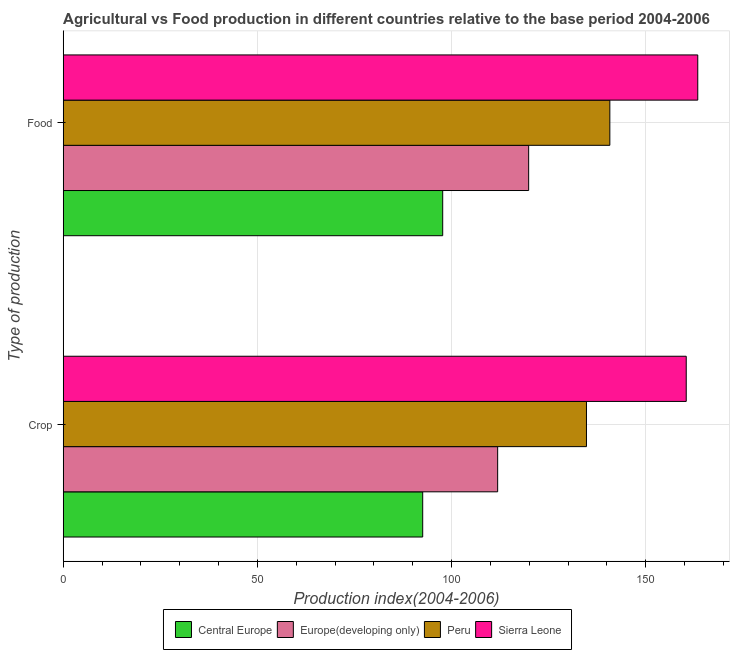How many different coloured bars are there?
Make the answer very short. 4. How many groups of bars are there?
Give a very brief answer. 2. Are the number of bars per tick equal to the number of legend labels?
Make the answer very short. Yes. Are the number of bars on each tick of the Y-axis equal?
Your response must be concise. Yes. How many bars are there on the 1st tick from the top?
Your answer should be compact. 4. How many bars are there on the 1st tick from the bottom?
Make the answer very short. 4. What is the label of the 2nd group of bars from the top?
Keep it short and to the point. Crop. What is the crop production index in Europe(developing only)?
Keep it short and to the point. 111.86. Across all countries, what is the maximum food production index?
Provide a succinct answer. 163.39. Across all countries, what is the minimum crop production index?
Give a very brief answer. 92.56. In which country was the food production index maximum?
Make the answer very short. Sierra Leone. In which country was the crop production index minimum?
Make the answer very short. Central Europe. What is the total food production index in the graph?
Your answer should be very brief. 521.7. What is the difference between the crop production index in Europe(developing only) and that in Central Europe?
Provide a short and direct response. 19.3. What is the difference between the food production index in Sierra Leone and the crop production index in Peru?
Ensure brevity in your answer.  28.66. What is the average food production index per country?
Offer a terse response. 130.42. What is the difference between the food production index and crop production index in Central Europe?
Offer a very short reply. 5.15. In how many countries, is the food production index greater than 130 ?
Give a very brief answer. 2. What is the ratio of the crop production index in Europe(developing only) to that in Sierra Leone?
Offer a terse response. 0.7. Is the food production index in Peru less than that in Europe(developing only)?
Your answer should be very brief. No. What does the 1st bar from the top in Food represents?
Your answer should be very brief. Sierra Leone. What does the 4th bar from the bottom in Crop represents?
Your response must be concise. Sierra Leone. Are the values on the major ticks of X-axis written in scientific E-notation?
Offer a very short reply. No. Does the graph contain any zero values?
Offer a very short reply. No. Does the graph contain grids?
Your response must be concise. Yes. What is the title of the graph?
Your answer should be compact. Agricultural vs Food production in different countries relative to the base period 2004-2006. Does "Timor-Leste" appear as one of the legend labels in the graph?
Give a very brief answer. No. What is the label or title of the X-axis?
Offer a very short reply. Production index(2004-2006). What is the label or title of the Y-axis?
Offer a terse response. Type of production. What is the Production index(2004-2006) of Central Europe in Crop?
Provide a short and direct response. 92.56. What is the Production index(2004-2006) of Europe(developing only) in Crop?
Offer a very short reply. 111.86. What is the Production index(2004-2006) in Peru in Crop?
Offer a very short reply. 134.73. What is the Production index(2004-2006) of Sierra Leone in Crop?
Your response must be concise. 160.42. What is the Production index(2004-2006) of Central Europe in Food?
Your answer should be very brief. 97.71. What is the Production index(2004-2006) of Europe(developing only) in Food?
Your answer should be compact. 119.84. What is the Production index(2004-2006) of Peru in Food?
Your answer should be very brief. 140.75. What is the Production index(2004-2006) of Sierra Leone in Food?
Your answer should be compact. 163.39. Across all Type of production, what is the maximum Production index(2004-2006) of Central Europe?
Offer a terse response. 97.71. Across all Type of production, what is the maximum Production index(2004-2006) in Europe(developing only)?
Make the answer very short. 119.84. Across all Type of production, what is the maximum Production index(2004-2006) in Peru?
Keep it short and to the point. 140.75. Across all Type of production, what is the maximum Production index(2004-2006) in Sierra Leone?
Make the answer very short. 163.39. Across all Type of production, what is the minimum Production index(2004-2006) in Central Europe?
Ensure brevity in your answer.  92.56. Across all Type of production, what is the minimum Production index(2004-2006) of Europe(developing only)?
Your answer should be very brief. 111.86. Across all Type of production, what is the minimum Production index(2004-2006) in Peru?
Provide a short and direct response. 134.73. Across all Type of production, what is the minimum Production index(2004-2006) of Sierra Leone?
Your response must be concise. 160.42. What is the total Production index(2004-2006) of Central Europe in the graph?
Your answer should be very brief. 190.27. What is the total Production index(2004-2006) in Europe(developing only) in the graph?
Give a very brief answer. 231.71. What is the total Production index(2004-2006) of Peru in the graph?
Keep it short and to the point. 275.48. What is the total Production index(2004-2006) of Sierra Leone in the graph?
Your response must be concise. 323.81. What is the difference between the Production index(2004-2006) of Central Europe in Crop and that in Food?
Ensure brevity in your answer.  -5.15. What is the difference between the Production index(2004-2006) in Europe(developing only) in Crop and that in Food?
Offer a terse response. -7.98. What is the difference between the Production index(2004-2006) of Peru in Crop and that in Food?
Provide a succinct answer. -6.02. What is the difference between the Production index(2004-2006) of Sierra Leone in Crop and that in Food?
Provide a short and direct response. -2.97. What is the difference between the Production index(2004-2006) in Central Europe in Crop and the Production index(2004-2006) in Europe(developing only) in Food?
Make the answer very short. -27.28. What is the difference between the Production index(2004-2006) of Central Europe in Crop and the Production index(2004-2006) of Peru in Food?
Offer a terse response. -48.19. What is the difference between the Production index(2004-2006) in Central Europe in Crop and the Production index(2004-2006) in Sierra Leone in Food?
Ensure brevity in your answer.  -70.83. What is the difference between the Production index(2004-2006) of Europe(developing only) in Crop and the Production index(2004-2006) of Peru in Food?
Make the answer very short. -28.89. What is the difference between the Production index(2004-2006) in Europe(developing only) in Crop and the Production index(2004-2006) in Sierra Leone in Food?
Make the answer very short. -51.53. What is the difference between the Production index(2004-2006) of Peru in Crop and the Production index(2004-2006) of Sierra Leone in Food?
Your answer should be compact. -28.66. What is the average Production index(2004-2006) of Central Europe per Type of production?
Ensure brevity in your answer.  95.14. What is the average Production index(2004-2006) of Europe(developing only) per Type of production?
Offer a terse response. 115.85. What is the average Production index(2004-2006) in Peru per Type of production?
Your answer should be compact. 137.74. What is the average Production index(2004-2006) of Sierra Leone per Type of production?
Ensure brevity in your answer.  161.91. What is the difference between the Production index(2004-2006) of Central Europe and Production index(2004-2006) of Europe(developing only) in Crop?
Provide a succinct answer. -19.3. What is the difference between the Production index(2004-2006) in Central Europe and Production index(2004-2006) in Peru in Crop?
Your answer should be compact. -42.17. What is the difference between the Production index(2004-2006) of Central Europe and Production index(2004-2006) of Sierra Leone in Crop?
Your answer should be very brief. -67.86. What is the difference between the Production index(2004-2006) in Europe(developing only) and Production index(2004-2006) in Peru in Crop?
Ensure brevity in your answer.  -22.87. What is the difference between the Production index(2004-2006) in Europe(developing only) and Production index(2004-2006) in Sierra Leone in Crop?
Make the answer very short. -48.56. What is the difference between the Production index(2004-2006) of Peru and Production index(2004-2006) of Sierra Leone in Crop?
Ensure brevity in your answer.  -25.69. What is the difference between the Production index(2004-2006) of Central Europe and Production index(2004-2006) of Europe(developing only) in Food?
Offer a terse response. -22.13. What is the difference between the Production index(2004-2006) of Central Europe and Production index(2004-2006) of Peru in Food?
Keep it short and to the point. -43.04. What is the difference between the Production index(2004-2006) of Central Europe and Production index(2004-2006) of Sierra Leone in Food?
Your response must be concise. -65.68. What is the difference between the Production index(2004-2006) in Europe(developing only) and Production index(2004-2006) in Peru in Food?
Provide a succinct answer. -20.91. What is the difference between the Production index(2004-2006) in Europe(developing only) and Production index(2004-2006) in Sierra Leone in Food?
Provide a short and direct response. -43.55. What is the difference between the Production index(2004-2006) of Peru and Production index(2004-2006) of Sierra Leone in Food?
Your answer should be very brief. -22.64. What is the ratio of the Production index(2004-2006) of Central Europe in Crop to that in Food?
Provide a short and direct response. 0.95. What is the ratio of the Production index(2004-2006) in Europe(developing only) in Crop to that in Food?
Make the answer very short. 0.93. What is the ratio of the Production index(2004-2006) in Peru in Crop to that in Food?
Ensure brevity in your answer.  0.96. What is the ratio of the Production index(2004-2006) of Sierra Leone in Crop to that in Food?
Your response must be concise. 0.98. What is the difference between the highest and the second highest Production index(2004-2006) in Central Europe?
Your answer should be compact. 5.15. What is the difference between the highest and the second highest Production index(2004-2006) of Europe(developing only)?
Offer a very short reply. 7.98. What is the difference between the highest and the second highest Production index(2004-2006) of Peru?
Make the answer very short. 6.02. What is the difference between the highest and the second highest Production index(2004-2006) in Sierra Leone?
Your answer should be compact. 2.97. What is the difference between the highest and the lowest Production index(2004-2006) of Central Europe?
Provide a short and direct response. 5.15. What is the difference between the highest and the lowest Production index(2004-2006) of Europe(developing only)?
Provide a succinct answer. 7.98. What is the difference between the highest and the lowest Production index(2004-2006) in Peru?
Your response must be concise. 6.02. What is the difference between the highest and the lowest Production index(2004-2006) in Sierra Leone?
Your response must be concise. 2.97. 